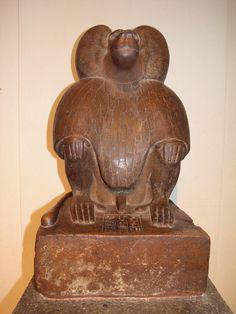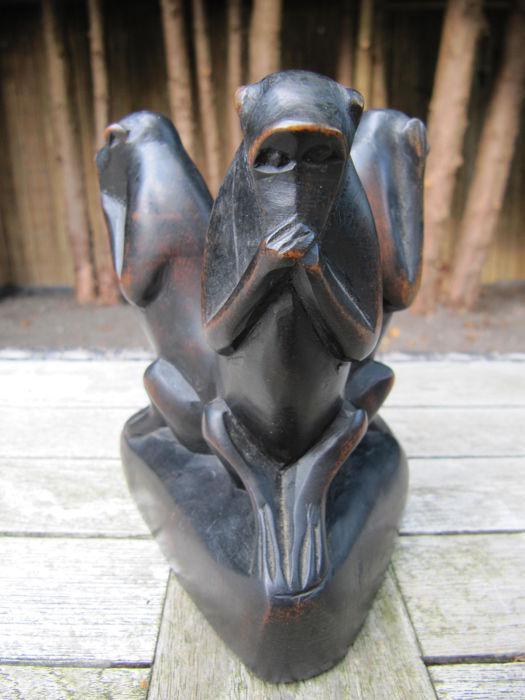The first image is the image on the left, the second image is the image on the right. For the images displayed, is the sentence "There is one statue that features one brown monkey and another statue that depicts three black monkeys in various poses." factually correct? Answer yes or no. Yes. 